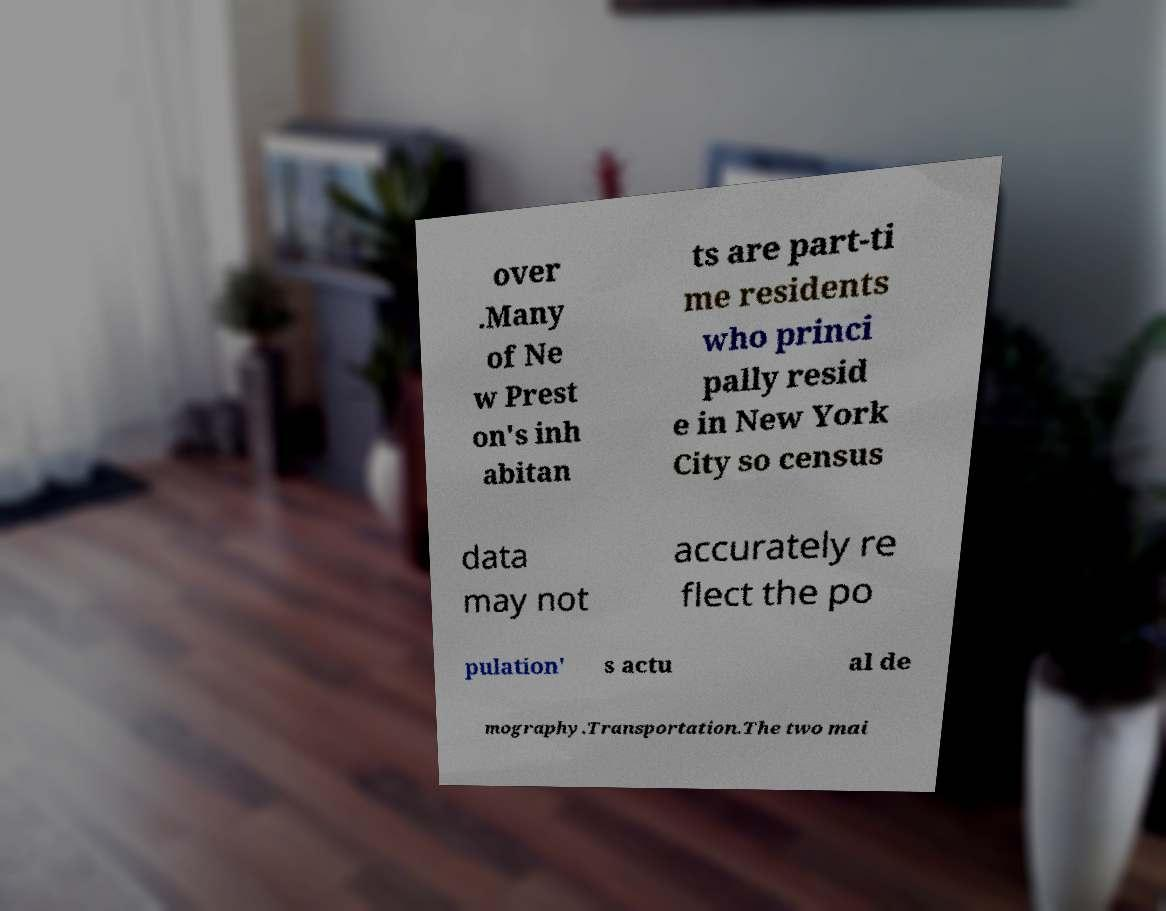What messages or text are displayed in this image? I need them in a readable, typed format. over .Many of Ne w Prest on's inh abitan ts are part-ti me residents who princi pally resid e in New York City so census data may not accurately re flect the po pulation' s actu al de mography.Transportation.The two mai 